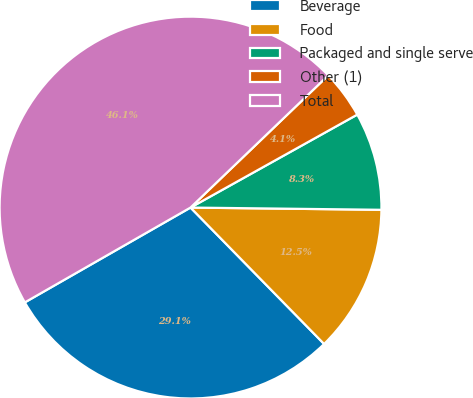<chart> <loc_0><loc_0><loc_500><loc_500><pie_chart><fcel>Beverage<fcel>Food<fcel>Packaged and single serve<fcel>Other (1)<fcel>Total<nl><fcel>29.06%<fcel>12.48%<fcel>8.28%<fcel>4.08%<fcel>46.1%<nl></chart> 